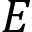Convert formula to latex. <formula><loc_0><loc_0><loc_500><loc_500>E</formula> 